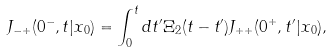Convert formula to latex. <formula><loc_0><loc_0><loc_500><loc_500>J _ { - + } ( 0 ^ { - } , t | x _ { 0 } ) = \int _ { 0 } ^ { t } d t ^ { \prime } \Xi _ { 2 } ( t - t ^ { \prime } ) J _ { + + } ( 0 ^ { + } , t ^ { \prime } | x _ { 0 } ) ,</formula> 